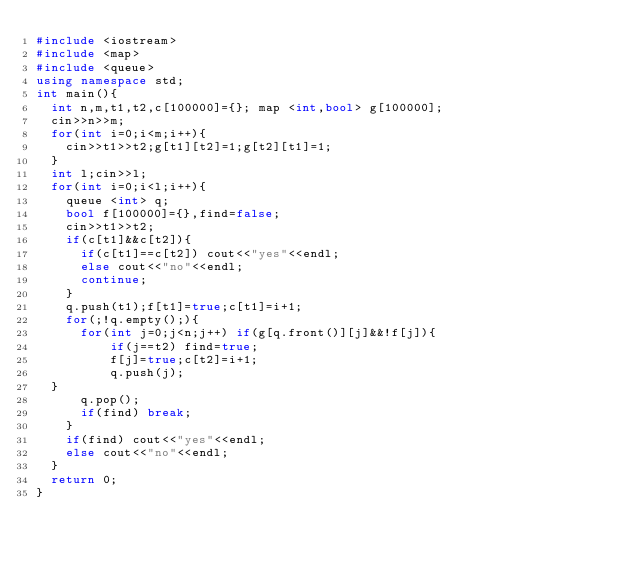Convert code to text. <code><loc_0><loc_0><loc_500><loc_500><_C++_>#include <iostream>
#include <map>
#include <queue>
using namespace std;
int main(){
  int n,m,t1,t2,c[100000]={}; map <int,bool> g[100000];
  cin>>n>>m;
  for(int i=0;i<m;i++){
    cin>>t1>>t2;g[t1][t2]=1;g[t2][t1]=1;
  }
  int l;cin>>l;
  for(int i=0;i<l;i++){
    queue <int> q;
    bool f[100000]={},find=false;
    cin>>t1>>t2;
    if(c[t1]&&c[t2]){
      if(c[t1]==c[t2]) cout<<"yes"<<endl;
      else cout<<"no"<<endl;
      continue;
    }
    q.push(t1);f[t1]=true;c[t1]=i+1;
    for(;!q.empty();){
      for(int j=0;j<n;j++) if(g[q.front()][j]&&!f[j]){
          if(j==t2) find=true;
          f[j]=true;c[t2]=i+1;
          q.push(j);
	}
      q.pop();
      if(find) break;
    }
    if(find) cout<<"yes"<<endl;
    else cout<<"no"<<endl;
  }
  return 0;
}</code> 